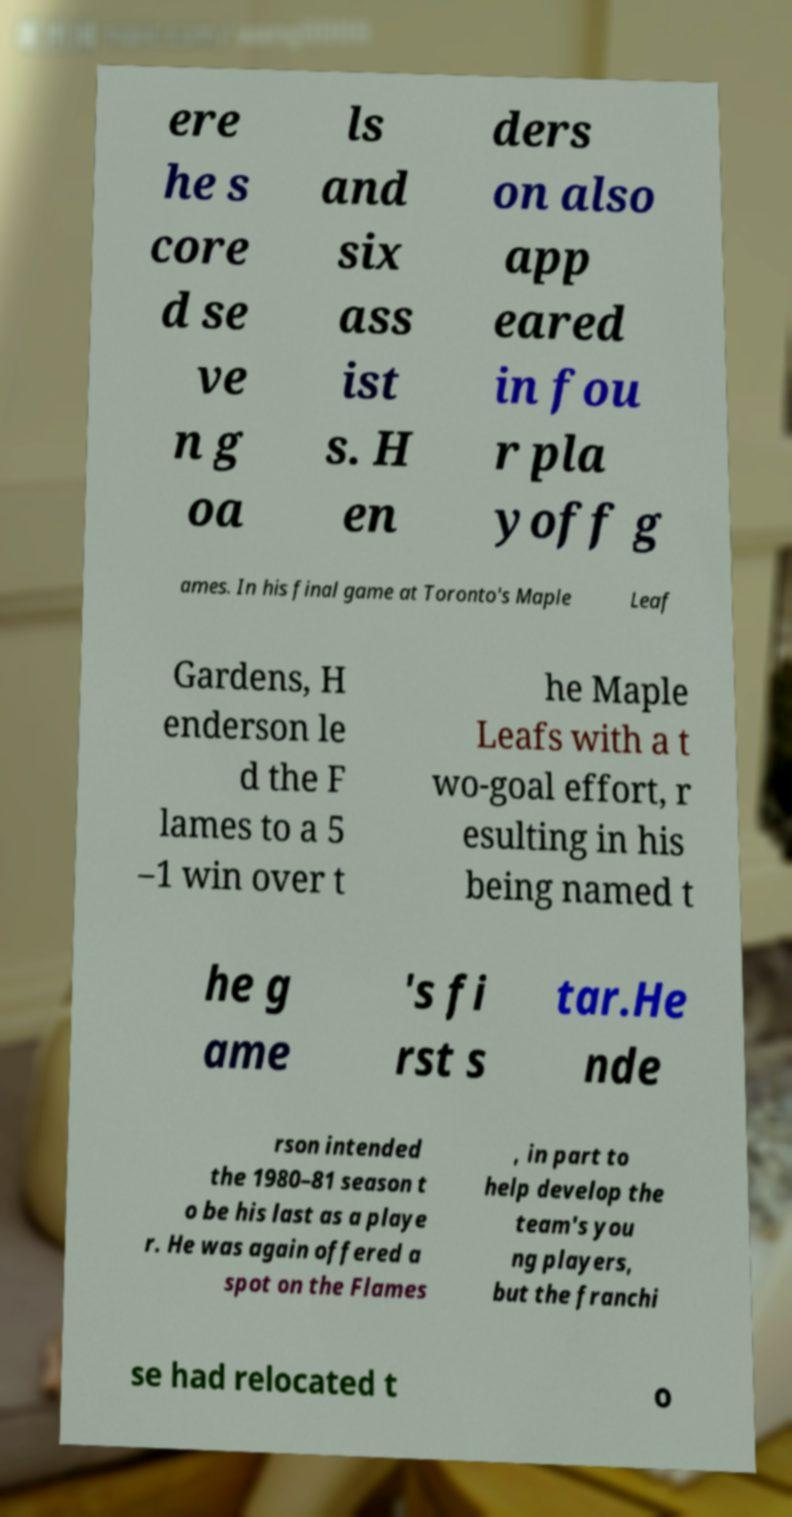Could you assist in decoding the text presented in this image and type it out clearly? ere he s core d se ve n g oa ls and six ass ist s. H en ders on also app eared in fou r pla yoff g ames. In his final game at Toronto's Maple Leaf Gardens, H enderson le d the F lames to a 5 –1 win over t he Maple Leafs with a t wo-goal effort, r esulting in his being named t he g ame 's fi rst s tar.He nde rson intended the 1980–81 season t o be his last as a playe r. He was again offered a spot on the Flames , in part to help develop the team's you ng players, but the franchi se had relocated t o 